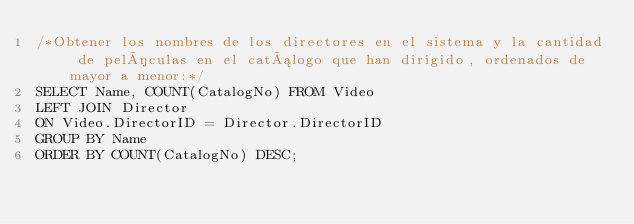<code> <loc_0><loc_0><loc_500><loc_500><_SQL_>/*Obtener los nombres de los directores en el sistema y la cantidad de películas en el catálogo que han dirigido, ordenados de mayor a menor:*/
SELECT Name, COUNT(CatalogNo) FROM Video
LEFT JOIN Director
ON Video.DirectorID = Director.DirectorID
GROUP BY Name 
ORDER BY COUNT(CatalogNo) DESC;</code> 